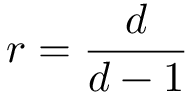Convert formula to latex. <formula><loc_0><loc_0><loc_500><loc_500>r = \frac { d } { d - 1 }</formula> 